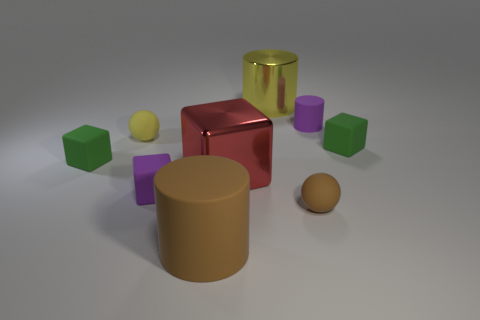The red block that is the same material as the yellow cylinder is what size? The red block, which appears to have the same reflective properties as the yellow cylinder, indicating they are possibly made of the same material, is large in size compared to the other objects in the image. 